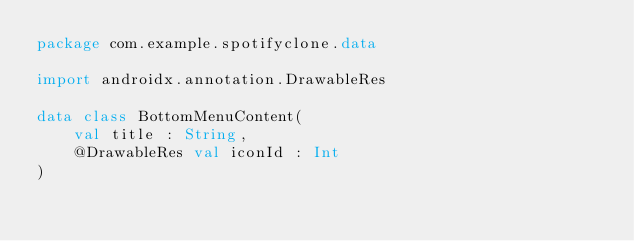Convert code to text. <code><loc_0><loc_0><loc_500><loc_500><_Kotlin_>package com.example.spotifyclone.data

import androidx.annotation.DrawableRes

data class BottomMenuContent(
    val title : String,
    @DrawableRes val iconId : Int
)
</code> 